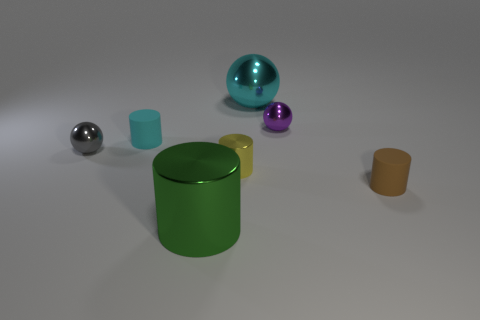How many other objects are the same size as the brown cylinder?
Ensure brevity in your answer.  4. There is a tiny brown matte thing; are there any large shiny cylinders right of it?
Make the answer very short. No. Is the color of the large ball the same as the shiny sphere that is in front of the tiny purple thing?
Provide a succinct answer. No. There is a small matte thing that is behind the small rubber object in front of the tiny rubber cylinder that is behind the brown object; what color is it?
Ensure brevity in your answer.  Cyan. Are there any large brown things of the same shape as the cyan rubber thing?
Ensure brevity in your answer.  No. What is the color of the metal sphere that is the same size as the green metallic cylinder?
Your answer should be very brief. Cyan. There is a large sphere behind the small gray metal thing; what is its material?
Offer a very short reply. Metal. Does the large object to the left of the cyan sphere have the same shape as the big metallic thing that is behind the gray metallic ball?
Your answer should be compact. No. Are there an equal number of green things that are right of the purple object and red rubber things?
Give a very brief answer. Yes. What number of small spheres are made of the same material as the tiny gray object?
Your answer should be very brief. 1. 